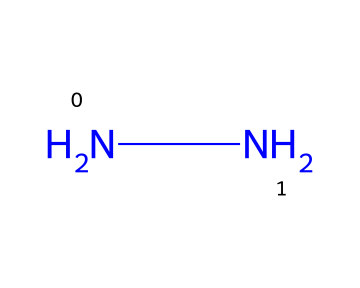What is the molecular formula of hydrazine? The SMILES representation 'NN' indicates that there are two nitrogen atoms connected, with no other atoms present. Therefore, the molecular formula is composed of just nitrogen, which is represented as N2.
Answer: N2 How many nitrogen atoms are in hydrazine? The SMILES representation shows two letters 'N', each representing a nitrogen atom. Therefore, by counting the nitrogen symbols, we find there are 2 nitrogen atoms.
Answer: 2 What type of chemical bond is present in hydrazine? The SMILES notation shows 'NN', indicating a single bond between the two nitrogen atoms. Thus, the bond type is determined by the connection as simple 'N-N'.
Answer: single bond What is the primary use of hydrazine in anti-corrosion coatings? Hydrazine is a reducing agent, which means it helps to neutralize corrosion by reducing the oxidation of metals in coatings. Its chemical properties contribute to inhibiting rust and other forms of corrosion.
Answer: reducing agent Which chemical structure characteristic makes hydrazine a good candidate for anti-corrosion coatings? Hydrazine features a simple structure with nitrogen-nitrogen bonding that provides a high density of reactive sites for chemical interactions, allowing it to effectively reduce corrosion processes.
Answer: reactive sites How does the structure of hydrazine relate to its stability in coatings? The absence of carbon and the simple diatomic structure DONOT introduce variability, making it stable in certain environments, hence its common use in coatings where reliability is crucial.
Answer: stability 